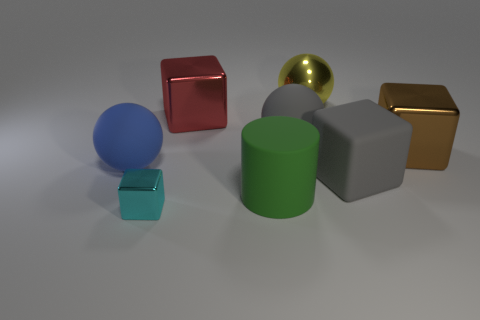If this were a scene from a short animation, what story could it be telling? This scene could represent the diversity and unity of characters in a story, where each object symbolizes a unique individual with their own personal characteristics. Together, they could embark on a collaborative adventure, learning from each other's differences and contributing to a common goal. 